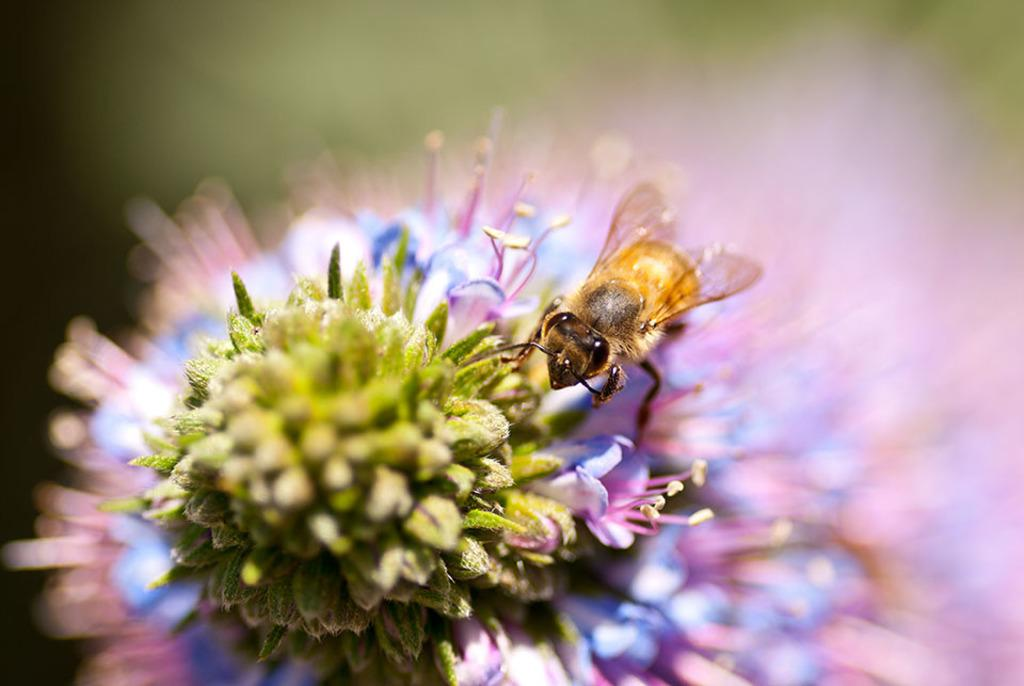What type of living organism can be seen in the image? There is a flower in the image. Are there any insects visible in the image? Yes, there is a fly in the image. What type of milk can be seen in the image? There is no milk present in the image; it features a flower and a fly. Is there a whip visible in the image? There is no whip present in the image. 